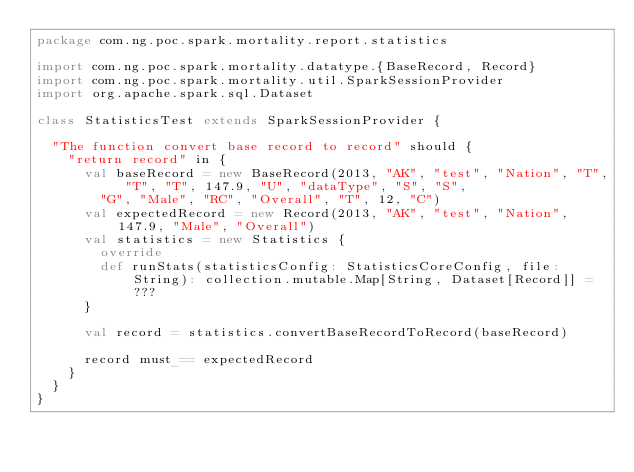<code> <loc_0><loc_0><loc_500><loc_500><_Scala_>package com.ng.poc.spark.mortality.report.statistics

import com.ng.poc.spark.mortality.datatype.{BaseRecord, Record}
import com.ng.poc.spark.mortality.util.SparkSessionProvider
import org.apache.spark.sql.Dataset

class StatisticsTest extends SparkSessionProvider {

  "The function convert base record to record" should {
    "return record" in {
      val baseRecord = new BaseRecord(2013, "AK", "test", "Nation", "T", "T", "T", 147.9, "U", "dataType", "S", "S",
        "G", "Male", "RC", "Overall", "T", 12, "C")
      val expectedRecord = new Record(2013, "AK", "test", "Nation", 147.9, "Male", "Overall")
      val statistics = new Statistics {
        override
        def runStats(statisticsConfig: StatisticsCoreConfig, file: String): collection.mutable.Map[String, Dataset[Record]] = ???
      }

      val record = statistics.convertBaseRecordToRecord(baseRecord)

      record must_== expectedRecord
    }
  }
}
</code> 